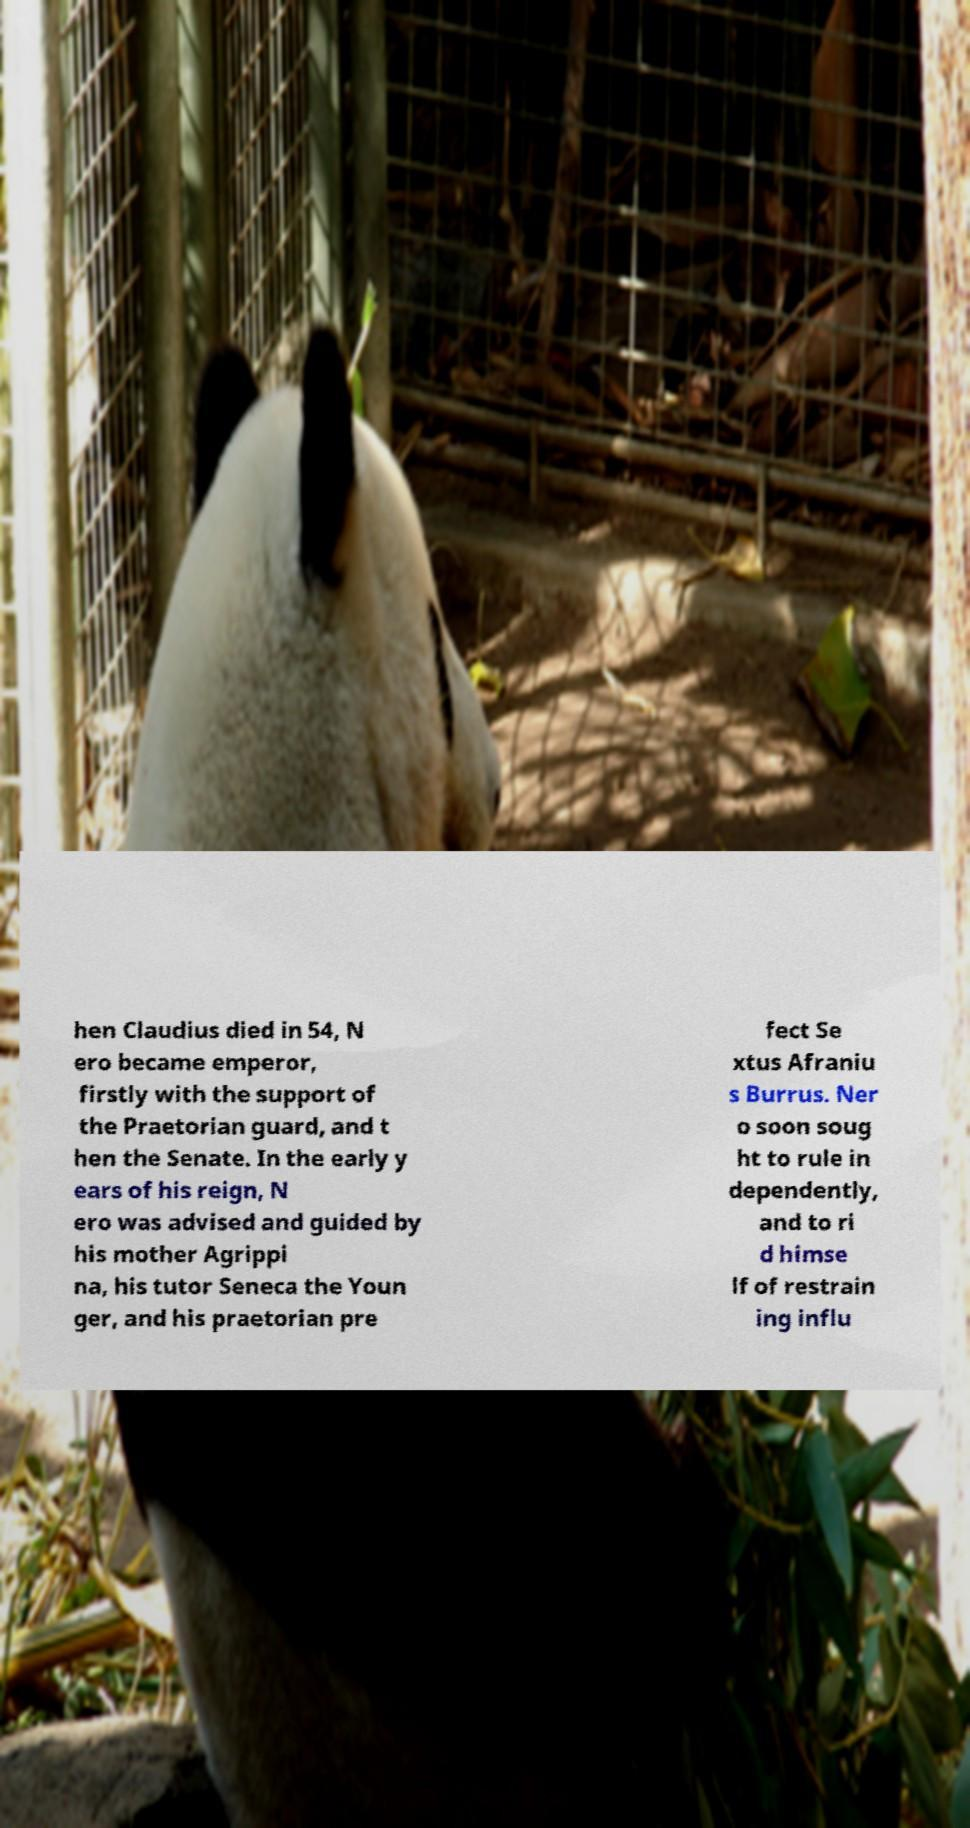There's text embedded in this image that I need extracted. Can you transcribe it verbatim? hen Claudius died in 54, N ero became emperor, firstly with the support of the Praetorian guard, and t hen the Senate. In the early y ears of his reign, N ero was advised and guided by his mother Agrippi na, his tutor Seneca the Youn ger, and his praetorian pre fect Se xtus Afraniu s Burrus. Ner o soon soug ht to rule in dependently, and to ri d himse lf of restrain ing influ 